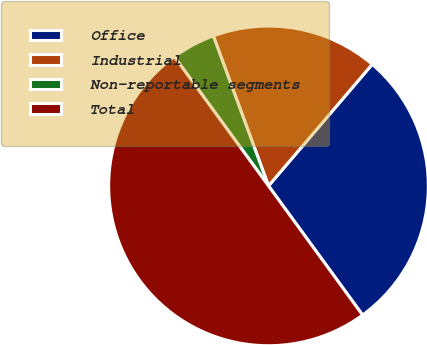Convert chart to OTSL. <chart><loc_0><loc_0><loc_500><loc_500><pie_chart><fcel>Office<fcel>Industrial<fcel>Non-reportable segments<fcel>Total<nl><fcel>28.74%<fcel>16.85%<fcel>4.41%<fcel>50.0%<nl></chart> 